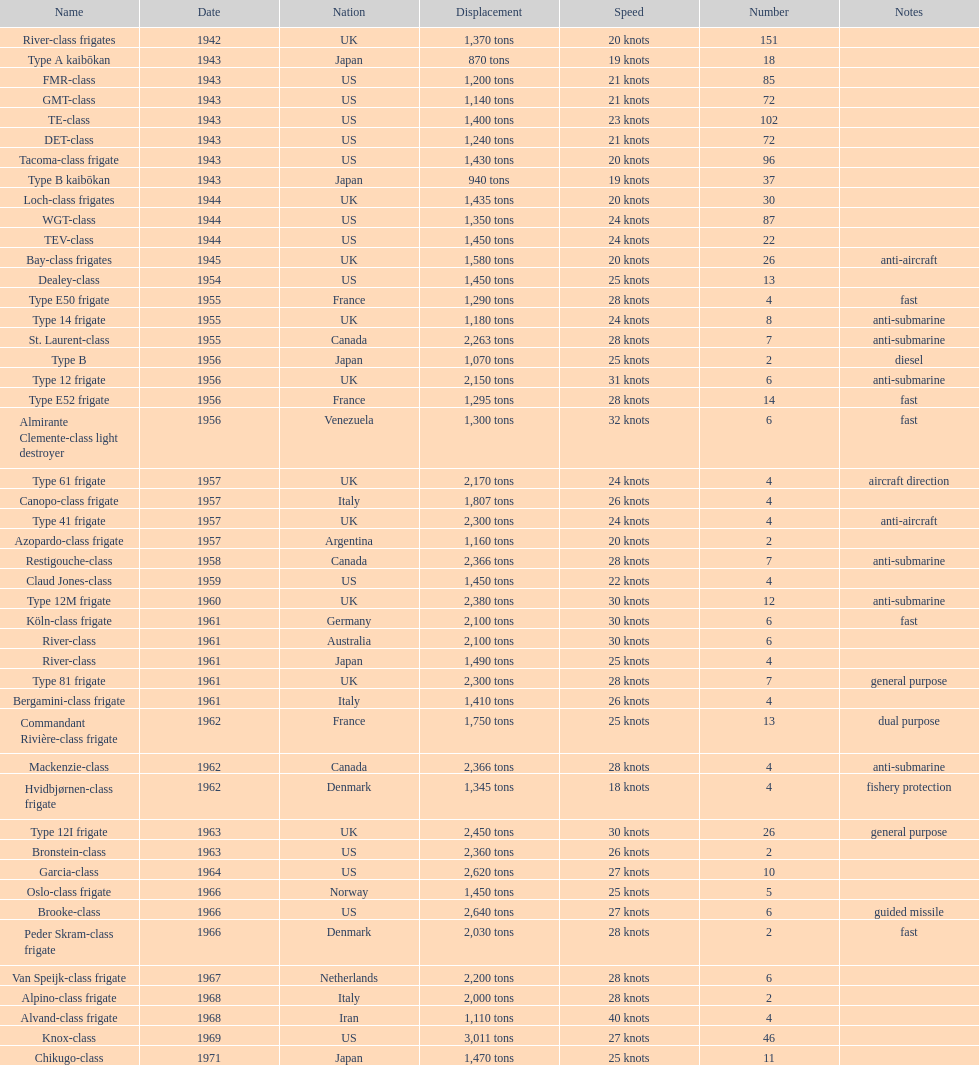Can you parse all the data within this table? {'header': ['Name', 'Date', 'Nation', 'Displacement', 'Speed', 'Number', 'Notes'], 'rows': [['River-class frigates', '1942', 'UK', '1,370 tons', '20 knots', '151', ''], ['Type A kaibōkan', '1943', 'Japan', '870 tons', '19 knots', '18', ''], ['FMR-class', '1943', 'US', '1,200 tons', '21 knots', '85', ''], ['GMT-class', '1943', 'US', '1,140 tons', '21 knots', '72', ''], ['TE-class', '1943', 'US', '1,400 tons', '23 knots', '102', ''], ['DET-class', '1943', 'US', '1,240 tons', '21 knots', '72', ''], ['Tacoma-class frigate', '1943', 'US', '1,430 tons', '20 knots', '96', ''], ['Type B kaibōkan', '1943', 'Japan', '940 tons', '19 knots', '37', ''], ['Loch-class frigates', '1944', 'UK', '1,435 tons', '20 knots', '30', ''], ['WGT-class', '1944', 'US', '1,350 tons', '24 knots', '87', ''], ['TEV-class', '1944', 'US', '1,450 tons', '24 knots', '22', ''], ['Bay-class frigates', '1945', 'UK', '1,580 tons', '20 knots', '26', 'anti-aircraft'], ['Dealey-class', '1954', 'US', '1,450 tons', '25 knots', '13', ''], ['Type E50 frigate', '1955', 'France', '1,290 tons', '28 knots', '4', 'fast'], ['Type 14 frigate', '1955', 'UK', '1,180 tons', '24 knots', '8', 'anti-submarine'], ['St. Laurent-class', '1955', 'Canada', '2,263 tons', '28 knots', '7', 'anti-submarine'], ['Type B', '1956', 'Japan', '1,070 tons', '25 knots', '2', 'diesel'], ['Type 12 frigate', '1956', 'UK', '2,150 tons', '31 knots', '6', 'anti-submarine'], ['Type E52 frigate', '1956', 'France', '1,295 tons', '28 knots', '14', 'fast'], ['Almirante Clemente-class light destroyer', '1956', 'Venezuela', '1,300 tons', '32 knots', '6', 'fast'], ['Type 61 frigate', '1957', 'UK', '2,170 tons', '24 knots', '4', 'aircraft direction'], ['Canopo-class frigate', '1957', 'Italy', '1,807 tons', '26 knots', '4', ''], ['Type 41 frigate', '1957', 'UK', '2,300 tons', '24 knots', '4', 'anti-aircraft'], ['Azopardo-class frigate', '1957', 'Argentina', '1,160 tons', '20 knots', '2', ''], ['Restigouche-class', '1958', 'Canada', '2,366 tons', '28 knots', '7', 'anti-submarine'], ['Claud Jones-class', '1959', 'US', '1,450 tons', '22 knots', '4', ''], ['Type 12M frigate', '1960', 'UK', '2,380 tons', '30 knots', '12', 'anti-submarine'], ['Köln-class frigate', '1961', 'Germany', '2,100 tons', '30 knots', '6', 'fast'], ['River-class', '1961', 'Australia', '2,100 tons', '30 knots', '6', ''], ['River-class', '1961', 'Japan', '1,490 tons', '25 knots', '4', ''], ['Type 81 frigate', '1961', 'UK', '2,300 tons', '28 knots', '7', 'general purpose'], ['Bergamini-class frigate', '1961', 'Italy', '1,410 tons', '26 knots', '4', ''], ['Commandant Rivière-class frigate', '1962', 'France', '1,750 tons', '25 knots', '13', 'dual purpose'], ['Mackenzie-class', '1962', 'Canada', '2,366 tons', '28 knots', '4', 'anti-submarine'], ['Hvidbjørnen-class frigate', '1962', 'Denmark', '1,345 tons', '18 knots', '4', 'fishery protection'], ['Type 12I frigate', '1963', 'UK', '2,450 tons', '30 knots', '26', 'general purpose'], ['Bronstein-class', '1963', 'US', '2,360 tons', '26 knots', '2', ''], ['Garcia-class', '1964', 'US', '2,620 tons', '27 knots', '10', ''], ['Oslo-class frigate', '1966', 'Norway', '1,450 tons', '25 knots', '5', ''], ['Brooke-class', '1966', 'US', '2,640 tons', '27 knots', '6', 'guided missile'], ['Peder Skram-class frigate', '1966', 'Denmark', '2,030 tons', '28 knots', '2', 'fast'], ['Van Speijk-class frigate', '1967', 'Netherlands', '2,200 tons', '28 knots', '6', ''], ['Alpino-class frigate', '1968', 'Italy', '2,000 tons', '28 knots', '2', ''], ['Alvand-class frigate', '1968', 'Iran', '1,110 tons', '40 knots', '4', ''], ['Knox-class', '1969', 'US', '3,011 tons', '27 knots', '46', ''], ['Chikugo-class', '1971', 'Japan', '1,470 tons', '25 knots', '11', '']]} What is the displacement of the te-class in tons? 1,400 tons. 